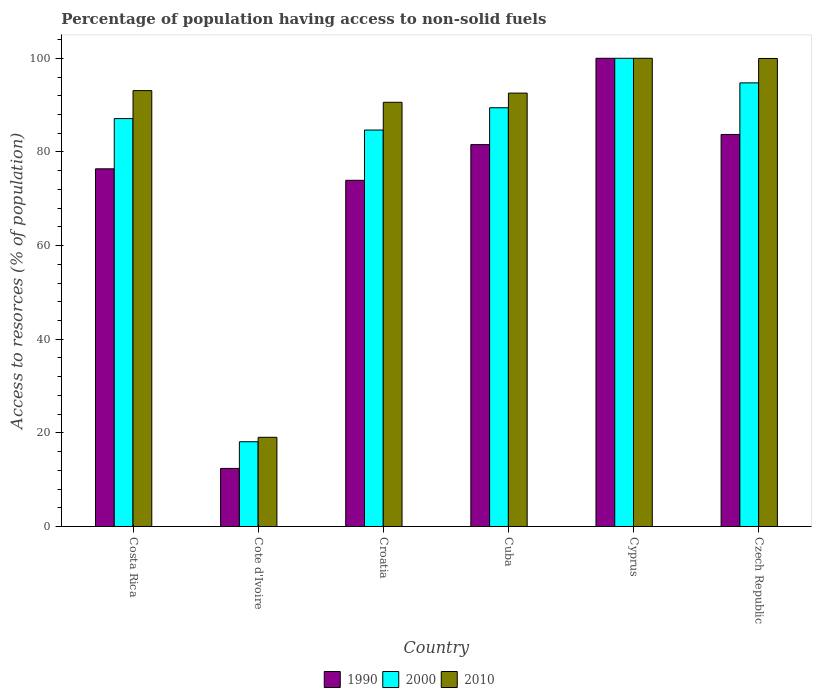How many groups of bars are there?
Your answer should be very brief. 6. Are the number of bars on each tick of the X-axis equal?
Offer a terse response. Yes. How many bars are there on the 4th tick from the left?
Offer a very short reply. 3. How many bars are there on the 2nd tick from the right?
Your answer should be very brief. 3. In how many cases, is the number of bars for a given country not equal to the number of legend labels?
Provide a short and direct response. 0. What is the percentage of population having access to non-solid fuels in 2000 in Czech Republic?
Your response must be concise. 94.75. Across all countries, what is the maximum percentage of population having access to non-solid fuels in 2010?
Your response must be concise. 100. Across all countries, what is the minimum percentage of population having access to non-solid fuels in 1990?
Give a very brief answer. 12.4. In which country was the percentage of population having access to non-solid fuels in 2010 maximum?
Give a very brief answer. Cyprus. In which country was the percentage of population having access to non-solid fuels in 2010 minimum?
Provide a succinct answer. Cote d'Ivoire. What is the total percentage of population having access to non-solid fuels in 2010 in the graph?
Ensure brevity in your answer.  495.27. What is the difference between the percentage of population having access to non-solid fuels in 1990 in Cyprus and that in Czech Republic?
Offer a very short reply. 16.27. What is the difference between the percentage of population having access to non-solid fuels in 2010 in Costa Rica and the percentage of population having access to non-solid fuels in 2000 in Cuba?
Offer a terse response. 3.66. What is the average percentage of population having access to non-solid fuels in 1990 per country?
Your answer should be very brief. 71.34. What is the difference between the percentage of population having access to non-solid fuels of/in 1990 and percentage of population having access to non-solid fuels of/in 2010 in Costa Rica?
Offer a terse response. -16.71. What is the ratio of the percentage of population having access to non-solid fuels in 2000 in Cuba to that in Czech Republic?
Provide a short and direct response. 0.94. What is the difference between the highest and the second highest percentage of population having access to non-solid fuels in 2000?
Make the answer very short. -10.56. What is the difference between the highest and the lowest percentage of population having access to non-solid fuels in 2010?
Provide a short and direct response. 80.95. Is the sum of the percentage of population having access to non-solid fuels in 2000 in Cote d'Ivoire and Czech Republic greater than the maximum percentage of population having access to non-solid fuels in 1990 across all countries?
Provide a short and direct response. Yes. What does the 1st bar from the left in Czech Republic represents?
Offer a very short reply. 1990. Is it the case that in every country, the sum of the percentage of population having access to non-solid fuels in 1990 and percentage of population having access to non-solid fuels in 2000 is greater than the percentage of population having access to non-solid fuels in 2010?
Offer a very short reply. Yes. Are all the bars in the graph horizontal?
Keep it short and to the point. No. Are the values on the major ticks of Y-axis written in scientific E-notation?
Make the answer very short. No. How many legend labels are there?
Ensure brevity in your answer.  3. How are the legend labels stacked?
Keep it short and to the point. Horizontal. What is the title of the graph?
Your answer should be compact. Percentage of population having access to non-solid fuels. Does "1961" appear as one of the legend labels in the graph?
Give a very brief answer. No. What is the label or title of the X-axis?
Your response must be concise. Country. What is the label or title of the Y-axis?
Make the answer very short. Access to resorces (% of population). What is the Access to resorces (% of population) in 1990 in Costa Rica?
Provide a short and direct response. 76.39. What is the Access to resorces (% of population) in 2000 in Costa Rica?
Provide a short and direct response. 87.12. What is the Access to resorces (% of population) of 2010 in Costa Rica?
Give a very brief answer. 93.1. What is the Access to resorces (% of population) in 1990 in Cote d'Ivoire?
Ensure brevity in your answer.  12.4. What is the Access to resorces (% of population) in 2000 in Cote d'Ivoire?
Offer a terse response. 18.1. What is the Access to resorces (% of population) in 2010 in Cote d'Ivoire?
Provide a succinct answer. 19.05. What is the Access to resorces (% of population) in 1990 in Croatia?
Offer a terse response. 73.94. What is the Access to resorces (% of population) of 2000 in Croatia?
Provide a succinct answer. 84.67. What is the Access to resorces (% of population) of 2010 in Croatia?
Your response must be concise. 90.6. What is the Access to resorces (% of population) in 1990 in Cuba?
Offer a terse response. 81.56. What is the Access to resorces (% of population) in 2000 in Cuba?
Give a very brief answer. 89.44. What is the Access to resorces (% of population) of 2010 in Cuba?
Give a very brief answer. 92.56. What is the Access to resorces (% of population) in 1990 in Cyprus?
Keep it short and to the point. 100. What is the Access to resorces (% of population) in 2000 in Cyprus?
Ensure brevity in your answer.  100. What is the Access to resorces (% of population) in 1990 in Czech Republic?
Keep it short and to the point. 83.73. What is the Access to resorces (% of population) of 2000 in Czech Republic?
Offer a very short reply. 94.75. What is the Access to resorces (% of population) in 2010 in Czech Republic?
Keep it short and to the point. 99.96. Across all countries, what is the maximum Access to resorces (% of population) in 1990?
Give a very brief answer. 100. Across all countries, what is the maximum Access to resorces (% of population) in 2010?
Provide a short and direct response. 100. Across all countries, what is the minimum Access to resorces (% of population) of 1990?
Your answer should be very brief. 12.4. Across all countries, what is the minimum Access to resorces (% of population) in 2000?
Offer a terse response. 18.1. Across all countries, what is the minimum Access to resorces (% of population) in 2010?
Provide a succinct answer. 19.05. What is the total Access to resorces (% of population) in 1990 in the graph?
Provide a short and direct response. 428.02. What is the total Access to resorces (% of population) in 2000 in the graph?
Your answer should be compact. 474.08. What is the total Access to resorces (% of population) of 2010 in the graph?
Offer a very short reply. 495.27. What is the difference between the Access to resorces (% of population) in 1990 in Costa Rica and that in Cote d'Ivoire?
Your answer should be very brief. 63.99. What is the difference between the Access to resorces (% of population) in 2000 in Costa Rica and that in Cote d'Ivoire?
Provide a short and direct response. 69.02. What is the difference between the Access to resorces (% of population) of 2010 in Costa Rica and that in Cote d'Ivoire?
Make the answer very short. 74.05. What is the difference between the Access to resorces (% of population) of 1990 in Costa Rica and that in Croatia?
Ensure brevity in your answer.  2.45. What is the difference between the Access to resorces (% of population) of 2000 in Costa Rica and that in Croatia?
Offer a very short reply. 2.45. What is the difference between the Access to resorces (% of population) in 2010 in Costa Rica and that in Croatia?
Offer a terse response. 2.5. What is the difference between the Access to resorces (% of population) in 1990 in Costa Rica and that in Cuba?
Keep it short and to the point. -5.17. What is the difference between the Access to resorces (% of population) of 2000 in Costa Rica and that in Cuba?
Provide a succinct answer. -2.32. What is the difference between the Access to resorces (% of population) in 2010 in Costa Rica and that in Cuba?
Offer a terse response. 0.53. What is the difference between the Access to resorces (% of population) of 1990 in Costa Rica and that in Cyprus?
Your answer should be compact. -23.61. What is the difference between the Access to resorces (% of population) in 2000 in Costa Rica and that in Cyprus?
Provide a short and direct response. -12.88. What is the difference between the Access to resorces (% of population) in 2010 in Costa Rica and that in Cyprus?
Your answer should be very brief. -6.9. What is the difference between the Access to resorces (% of population) of 1990 in Costa Rica and that in Czech Republic?
Your answer should be compact. -7.34. What is the difference between the Access to resorces (% of population) in 2000 in Costa Rica and that in Czech Republic?
Your answer should be compact. -7.63. What is the difference between the Access to resorces (% of population) of 2010 in Costa Rica and that in Czech Republic?
Keep it short and to the point. -6.87. What is the difference between the Access to resorces (% of population) in 1990 in Cote d'Ivoire and that in Croatia?
Give a very brief answer. -61.54. What is the difference between the Access to resorces (% of population) in 2000 in Cote d'Ivoire and that in Croatia?
Provide a succinct answer. -66.57. What is the difference between the Access to resorces (% of population) of 2010 in Cote d'Ivoire and that in Croatia?
Give a very brief answer. -71.55. What is the difference between the Access to resorces (% of population) of 1990 in Cote d'Ivoire and that in Cuba?
Your answer should be very brief. -69.16. What is the difference between the Access to resorces (% of population) of 2000 in Cote d'Ivoire and that in Cuba?
Your answer should be compact. -71.33. What is the difference between the Access to resorces (% of population) in 2010 in Cote d'Ivoire and that in Cuba?
Offer a terse response. -73.52. What is the difference between the Access to resorces (% of population) in 1990 in Cote d'Ivoire and that in Cyprus?
Provide a succinct answer. -87.6. What is the difference between the Access to resorces (% of population) of 2000 in Cote d'Ivoire and that in Cyprus?
Provide a succinct answer. -81.9. What is the difference between the Access to resorces (% of population) of 2010 in Cote d'Ivoire and that in Cyprus?
Your response must be concise. -80.95. What is the difference between the Access to resorces (% of population) in 1990 in Cote d'Ivoire and that in Czech Republic?
Provide a short and direct response. -71.32. What is the difference between the Access to resorces (% of population) in 2000 in Cote d'Ivoire and that in Czech Republic?
Ensure brevity in your answer.  -76.65. What is the difference between the Access to resorces (% of population) of 2010 in Cote d'Ivoire and that in Czech Republic?
Ensure brevity in your answer.  -80.92. What is the difference between the Access to resorces (% of population) of 1990 in Croatia and that in Cuba?
Ensure brevity in your answer.  -7.62. What is the difference between the Access to resorces (% of population) of 2000 in Croatia and that in Cuba?
Keep it short and to the point. -4.76. What is the difference between the Access to resorces (% of population) in 2010 in Croatia and that in Cuba?
Your answer should be very brief. -1.96. What is the difference between the Access to resorces (% of population) of 1990 in Croatia and that in Cyprus?
Ensure brevity in your answer.  -26.06. What is the difference between the Access to resorces (% of population) of 2000 in Croatia and that in Cyprus?
Your answer should be compact. -15.33. What is the difference between the Access to resorces (% of population) in 1990 in Croatia and that in Czech Republic?
Ensure brevity in your answer.  -9.79. What is the difference between the Access to resorces (% of population) of 2000 in Croatia and that in Czech Republic?
Give a very brief answer. -10.08. What is the difference between the Access to resorces (% of population) in 2010 in Croatia and that in Czech Republic?
Your response must be concise. -9.36. What is the difference between the Access to resorces (% of population) in 1990 in Cuba and that in Cyprus?
Keep it short and to the point. -18.44. What is the difference between the Access to resorces (% of population) in 2000 in Cuba and that in Cyprus?
Your response must be concise. -10.56. What is the difference between the Access to resorces (% of population) in 2010 in Cuba and that in Cyprus?
Offer a very short reply. -7.44. What is the difference between the Access to resorces (% of population) of 1990 in Cuba and that in Czech Republic?
Make the answer very short. -2.17. What is the difference between the Access to resorces (% of population) of 2000 in Cuba and that in Czech Republic?
Ensure brevity in your answer.  -5.31. What is the difference between the Access to resorces (% of population) of 2010 in Cuba and that in Czech Republic?
Your answer should be compact. -7.4. What is the difference between the Access to resorces (% of population) of 1990 in Cyprus and that in Czech Republic?
Your response must be concise. 16.27. What is the difference between the Access to resorces (% of population) in 2000 in Cyprus and that in Czech Republic?
Offer a very short reply. 5.25. What is the difference between the Access to resorces (% of population) in 2010 in Cyprus and that in Czech Republic?
Your answer should be very brief. 0.04. What is the difference between the Access to resorces (% of population) in 1990 in Costa Rica and the Access to resorces (% of population) in 2000 in Cote d'Ivoire?
Provide a succinct answer. 58.29. What is the difference between the Access to resorces (% of population) of 1990 in Costa Rica and the Access to resorces (% of population) of 2010 in Cote d'Ivoire?
Your response must be concise. 57.34. What is the difference between the Access to resorces (% of population) in 2000 in Costa Rica and the Access to resorces (% of population) in 2010 in Cote d'Ivoire?
Provide a succinct answer. 68.07. What is the difference between the Access to resorces (% of population) of 1990 in Costa Rica and the Access to resorces (% of population) of 2000 in Croatia?
Provide a succinct answer. -8.28. What is the difference between the Access to resorces (% of population) in 1990 in Costa Rica and the Access to resorces (% of population) in 2010 in Croatia?
Your response must be concise. -14.21. What is the difference between the Access to resorces (% of population) of 2000 in Costa Rica and the Access to resorces (% of population) of 2010 in Croatia?
Your response must be concise. -3.48. What is the difference between the Access to resorces (% of population) in 1990 in Costa Rica and the Access to resorces (% of population) in 2000 in Cuba?
Your answer should be compact. -13.05. What is the difference between the Access to resorces (% of population) of 1990 in Costa Rica and the Access to resorces (% of population) of 2010 in Cuba?
Give a very brief answer. -16.17. What is the difference between the Access to resorces (% of population) of 2000 in Costa Rica and the Access to resorces (% of population) of 2010 in Cuba?
Your answer should be compact. -5.44. What is the difference between the Access to resorces (% of population) of 1990 in Costa Rica and the Access to resorces (% of population) of 2000 in Cyprus?
Ensure brevity in your answer.  -23.61. What is the difference between the Access to resorces (% of population) in 1990 in Costa Rica and the Access to resorces (% of population) in 2010 in Cyprus?
Give a very brief answer. -23.61. What is the difference between the Access to resorces (% of population) of 2000 in Costa Rica and the Access to resorces (% of population) of 2010 in Cyprus?
Your answer should be compact. -12.88. What is the difference between the Access to resorces (% of population) of 1990 in Costa Rica and the Access to resorces (% of population) of 2000 in Czech Republic?
Offer a terse response. -18.36. What is the difference between the Access to resorces (% of population) of 1990 in Costa Rica and the Access to resorces (% of population) of 2010 in Czech Republic?
Ensure brevity in your answer.  -23.57. What is the difference between the Access to resorces (% of population) in 2000 in Costa Rica and the Access to resorces (% of population) in 2010 in Czech Republic?
Make the answer very short. -12.84. What is the difference between the Access to resorces (% of population) of 1990 in Cote d'Ivoire and the Access to resorces (% of population) of 2000 in Croatia?
Make the answer very short. -72.27. What is the difference between the Access to resorces (% of population) of 1990 in Cote d'Ivoire and the Access to resorces (% of population) of 2010 in Croatia?
Offer a terse response. -78.2. What is the difference between the Access to resorces (% of population) in 2000 in Cote d'Ivoire and the Access to resorces (% of population) in 2010 in Croatia?
Your answer should be compact. -72.5. What is the difference between the Access to resorces (% of population) in 1990 in Cote d'Ivoire and the Access to resorces (% of population) in 2000 in Cuba?
Offer a terse response. -77.03. What is the difference between the Access to resorces (% of population) in 1990 in Cote d'Ivoire and the Access to resorces (% of population) in 2010 in Cuba?
Ensure brevity in your answer.  -80.16. What is the difference between the Access to resorces (% of population) of 2000 in Cote d'Ivoire and the Access to resorces (% of population) of 2010 in Cuba?
Give a very brief answer. -74.46. What is the difference between the Access to resorces (% of population) of 1990 in Cote d'Ivoire and the Access to resorces (% of population) of 2000 in Cyprus?
Your response must be concise. -87.6. What is the difference between the Access to resorces (% of population) in 1990 in Cote d'Ivoire and the Access to resorces (% of population) in 2010 in Cyprus?
Your answer should be very brief. -87.6. What is the difference between the Access to resorces (% of population) of 2000 in Cote d'Ivoire and the Access to resorces (% of population) of 2010 in Cyprus?
Make the answer very short. -81.9. What is the difference between the Access to resorces (% of population) in 1990 in Cote d'Ivoire and the Access to resorces (% of population) in 2000 in Czech Republic?
Provide a short and direct response. -82.35. What is the difference between the Access to resorces (% of population) of 1990 in Cote d'Ivoire and the Access to resorces (% of population) of 2010 in Czech Republic?
Make the answer very short. -87.56. What is the difference between the Access to resorces (% of population) in 2000 in Cote d'Ivoire and the Access to resorces (% of population) in 2010 in Czech Republic?
Offer a terse response. -81.86. What is the difference between the Access to resorces (% of population) in 1990 in Croatia and the Access to resorces (% of population) in 2000 in Cuba?
Give a very brief answer. -15.5. What is the difference between the Access to resorces (% of population) in 1990 in Croatia and the Access to resorces (% of population) in 2010 in Cuba?
Offer a terse response. -18.62. What is the difference between the Access to resorces (% of population) of 2000 in Croatia and the Access to resorces (% of population) of 2010 in Cuba?
Your answer should be compact. -7.89. What is the difference between the Access to resorces (% of population) of 1990 in Croatia and the Access to resorces (% of population) of 2000 in Cyprus?
Give a very brief answer. -26.06. What is the difference between the Access to resorces (% of population) in 1990 in Croatia and the Access to resorces (% of population) in 2010 in Cyprus?
Offer a very short reply. -26.06. What is the difference between the Access to resorces (% of population) of 2000 in Croatia and the Access to resorces (% of population) of 2010 in Cyprus?
Keep it short and to the point. -15.33. What is the difference between the Access to resorces (% of population) in 1990 in Croatia and the Access to resorces (% of population) in 2000 in Czech Republic?
Give a very brief answer. -20.81. What is the difference between the Access to resorces (% of population) in 1990 in Croatia and the Access to resorces (% of population) in 2010 in Czech Republic?
Make the answer very short. -26.02. What is the difference between the Access to resorces (% of population) in 2000 in Croatia and the Access to resorces (% of population) in 2010 in Czech Republic?
Give a very brief answer. -15.29. What is the difference between the Access to resorces (% of population) in 1990 in Cuba and the Access to resorces (% of population) in 2000 in Cyprus?
Your response must be concise. -18.44. What is the difference between the Access to resorces (% of population) in 1990 in Cuba and the Access to resorces (% of population) in 2010 in Cyprus?
Ensure brevity in your answer.  -18.44. What is the difference between the Access to resorces (% of population) in 2000 in Cuba and the Access to resorces (% of population) in 2010 in Cyprus?
Your answer should be compact. -10.56. What is the difference between the Access to resorces (% of population) of 1990 in Cuba and the Access to resorces (% of population) of 2000 in Czech Republic?
Your answer should be very brief. -13.19. What is the difference between the Access to resorces (% of population) of 1990 in Cuba and the Access to resorces (% of population) of 2010 in Czech Republic?
Make the answer very short. -18.4. What is the difference between the Access to resorces (% of population) in 2000 in Cuba and the Access to resorces (% of population) in 2010 in Czech Republic?
Keep it short and to the point. -10.53. What is the difference between the Access to resorces (% of population) in 1990 in Cyprus and the Access to resorces (% of population) in 2000 in Czech Republic?
Offer a very short reply. 5.25. What is the difference between the Access to resorces (% of population) in 1990 in Cyprus and the Access to resorces (% of population) in 2010 in Czech Republic?
Ensure brevity in your answer.  0.04. What is the difference between the Access to resorces (% of population) in 2000 in Cyprus and the Access to resorces (% of population) in 2010 in Czech Republic?
Keep it short and to the point. 0.04. What is the average Access to resorces (% of population) of 1990 per country?
Offer a terse response. 71.34. What is the average Access to resorces (% of population) in 2000 per country?
Keep it short and to the point. 79.01. What is the average Access to resorces (% of population) of 2010 per country?
Your answer should be compact. 82.55. What is the difference between the Access to resorces (% of population) in 1990 and Access to resorces (% of population) in 2000 in Costa Rica?
Offer a terse response. -10.73. What is the difference between the Access to resorces (% of population) in 1990 and Access to resorces (% of population) in 2010 in Costa Rica?
Make the answer very short. -16.71. What is the difference between the Access to resorces (% of population) of 2000 and Access to resorces (% of population) of 2010 in Costa Rica?
Provide a short and direct response. -5.98. What is the difference between the Access to resorces (% of population) in 1990 and Access to resorces (% of population) in 2000 in Cote d'Ivoire?
Make the answer very short. -5.7. What is the difference between the Access to resorces (% of population) in 1990 and Access to resorces (% of population) in 2010 in Cote d'Ivoire?
Your answer should be compact. -6.64. What is the difference between the Access to resorces (% of population) of 2000 and Access to resorces (% of population) of 2010 in Cote d'Ivoire?
Your answer should be very brief. -0.95. What is the difference between the Access to resorces (% of population) of 1990 and Access to resorces (% of population) of 2000 in Croatia?
Your response must be concise. -10.73. What is the difference between the Access to resorces (% of population) in 1990 and Access to resorces (% of population) in 2010 in Croatia?
Provide a succinct answer. -16.66. What is the difference between the Access to resorces (% of population) of 2000 and Access to resorces (% of population) of 2010 in Croatia?
Make the answer very short. -5.93. What is the difference between the Access to resorces (% of population) of 1990 and Access to resorces (% of population) of 2000 in Cuba?
Your answer should be compact. -7.88. What is the difference between the Access to resorces (% of population) of 1990 and Access to resorces (% of population) of 2010 in Cuba?
Your answer should be very brief. -11. What is the difference between the Access to resorces (% of population) of 2000 and Access to resorces (% of population) of 2010 in Cuba?
Your answer should be compact. -3.13. What is the difference between the Access to resorces (% of population) in 1990 and Access to resorces (% of population) in 2010 in Cyprus?
Give a very brief answer. 0. What is the difference between the Access to resorces (% of population) in 1990 and Access to resorces (% of population) in 2000 in Czech Republic?
Provide a succinct answer. -11.02. What is the difference between the Access to resorces (% of population) in 1990 and Access to resorces (% of population) in 2010 in Czech Republic?
Offer a very short reply. -16.24. What is the difference between the Access to resorces (% of population) in 2000 and Access to resorces (% of population) in 2010 in Czech Republic?
Provide a short and direct response. -5.21. What is the ratio of the Access to resorces (% of population) of 1990 in Costa Rica to that in Cote d'Ivoire?
Give a very brief answer. 6.16. What is the ratio of the Access to resorces (% of population) in 2000 in Costa Rica to that in Cote d'Ivoire?
Your answer should be compact. 4.81. What is the ratio of the Access to resorces (% of population) in 2010 in Costa Rica to that in Cote d'Ivoire?
Give a very brief answer. 4.89. What is the ratio of the Access to resorces (% of population) of 1990 in Costa Rica to that in Croatia?
Ensure brevity in your answer.  1.03. What is the ratio of the Access to resorces (% of population) of 2000 in Costa Rica to that in Croatia?
Offer a terse response. 1.03. What is the ratio of the Access to resorces (% of population) in 2010 in Costa Rica to that in Croatia?
Give a very brief answer. 1.03. What is the ratio of the Access to resorces (% of population) in 1990 in Costa Rica to that in Cuba?
Provide a succinct answer. 0.94. What is the ratio of the Access to resorces (% of population) of 2000 in Costa Rica to that in Cuba?
Make the answer very short. 0.97. What is the ratio of the Access to resorces (% of population) of 2010 in Costa Rica to that in Cuba?
Give a very brief answer. 1.01. What is the ratio of the Access to resorces (% of population) in 1990 in Costa Rica to that in Cyprus?
Offer a terse response. 0.76. What is the ratio of the Access to resorces (% of population) in 2000 in Costa Rica to that in Cyprus?
Provide a short and direct response. 0.87. What is the ratio of the Access to resorces (% of population) in 1990 in Costa Rica to that in Czech Republic?
Your response must be concise. 0.91. What is the ratio of the Access to resorces (% of population) of 2000 in Costa Rica to that in Czech Republic?
Make the answer very short. 0.92. What is the ratio of the Access to resorces (% of population) in 2010 in Costa Rica to that in Czech Republic?
Provide a succinct answer. 0.93. What is the ratio of the Access to resorces (% of population) in 1990 in Cote d'Ivoire to that in Croatia?
Make the answer very short. 0.17. What is the ratio of the Access to resorces (% of population) of 2000 in Cote d'Ivoire to that in Croatia?
Your response must be concise. 0.21. What is the ratio of the Access to resorces (% of population) of 2010 in Cote d'Ivoire to that in Croatia?
Give a very brief answer. 0.21. What is the ratio of the Access to resorces (% of population) in 1990 in Cote d'Ivoire to that in Cuba?
Give a very brief answer. 0.15. What is the ratio of the Access to resorces (% of population) in 2000 in Cote d'Ivoire to that in Cuba?
Provide a short and direct response. 0.2. What is the ratio of the Access to resorces (% of population) of 2010 in Cote d'Ivoire to that in Cuba?
Your answer should be compact. 0.21. What is the ratio of the Access to resorces (% of population) in 1990 in Cote d'Ivoire to that in Cyprus?
Ensure brevity in your answer.  0.12. What is the ratio of the Access to resorces (% of population) of 2000 in Cote d'Ivoire to that in Cyprus?
Give a very brief answer. 0.18. What is the ratio of the Access to resorces (% of population) of 2010 in Cote d'Ivoire to that in Cyprus?
Ensure brevity in your answer.  0.19. What is the ratio of the Access to resorces (% of population) in 1990 in Cote d'Ivoire to that in Czech Republic?
Your answer should be compact. 0.15. What is the ratio of the Access to resorces (% of population) of 2000 in Cote d'Ivoire to that in Czech Republic?
Keep it short and to the point. 0.19. What is the ratio of the Access to resorces (% of population) in 2010 in Cote d'Ivoire to that in Czech Republic?
Give a very brief answer. 0.19. What is the ratio of the Access to resorces (% of population) of 1990 in Croatia to that in Cuba?
Your answer should be compact. 0.91. What is the ratio of the Access to resorces (% of population) of 2000 in Croatia to that in Cuba?
Keep it short and to the point. 0.95. What is the ratio of the Access to resorces (% of population) of 2010 in Croatia to that in Cuba?
Your response must be concise. 0.98. What is the ratio of the Access to resorces (% of population) in 1990 in Croatia to that in Cyprus?
Keep it short and to the point. 0.74. What is the ratio of the Access to resorces (% of population) of 2000 in Croatia to that in Cyprus?
Provide a succinct answer. 0.85. What is the ratio of the Access to resorces (% of population) of 2010 in Croatia to that in Cyprus?
Your answer should be compact. 0.91. What is the ratio of the Access to resorces (% of population) in 1990 in Croatia to that in Czech Republic?
Give a very brief answer. 0.88. What is the ratio of the Access to resorces (% of population) of 2000 in Croatia to that in Czech Republic?
Ensure brevity in your answer.  0.89. What is the ratio of the Access to resorces (% of population) of 2010 in Croatia to that in Czech Republic?
Offer a very short reply. 0.91. What is the ratio of the Access to resorces (% of population) of 1990 in Cuba to that in Cyprus?
Give a very brief answer. 0.82. What is the ratio of the Access to resorces (% of population) of 2000 in Cuba to that in Cyprus?
Provide a succinct answer. 0.89. What is the ratio of the Access to resorces (% of population) in 2010 in Cuba to that in Cyprus?
Make the answer very short. 0.93. What is the ratio of the Access to resorces (% of population) of 1990 in Cuba to that in Czech Republic?
Make the answer very short. 0.97. What is the ratio of the Access to resorces (% of population) of 2000 in Cuba to that in Czech Republic?
Your answer should be very brief. 0.94. What is the ratio of the Access to resorces (% of population) in 2010 in Cuba to that in Czech Republic?
Your answer should be very brief. 0.93. What is the ratio of the Access to resorces (% of population) of 1990 in Cyprus to that in Czech Republic?
Provide a short and direct response. 1.19. What is the ratio of the Access to resorces (% of population) of 2000 in Cyprus to that in Czech Republic?
Your answer should be compact. 1.06. What is the ratio of the Access to resorces (% of population) in 2010 in Cyprus to that in Czech Republic?
Keep it short and to the point. 1. What is the difference between the highest and the second highest Access to resorces (% of population) in 1990?
Make the answer very short. 16.27. What is the difference between the highest and the second highest Access to resorces (% of population) in 2000?
Keep it short and to the point. 5.25. What is the difference between the highest and the second highest Access to resorces (% of population) of 2010?
Make the answer very short. 0.04. What is the difference between the highest and the lowest Access to resorces (% of population) in 1990?
Give a very brief answer. 87.6. What is the difference between the highest and the lowest Access to resorces (% of population) in 2000?
Keep it short and to the point. 81.9. What is the difference between the highest and the lowest Access to resorces (% of population) of 2010?
Your response must be concise. 80.95. 